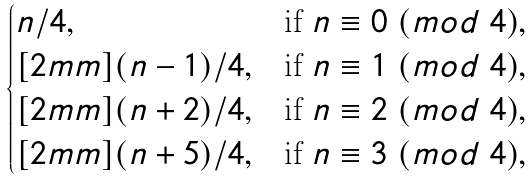<formula> <loc_0><loc_0><loc_500><loc_500>\begin{cases} n / 4 , & \text {if } n \equiv 0 \ ( m o d \ 4 ) , \\ [ 2 m m ] ( n - 1 ) / 4 , & \text {if } n \equiv 1 \ ( m o d \ 4 ) , \\ [ 2 m m ] ( n + 2 ) / 4 , & \text {if } n \equiv 2 \ ( m o d \ 4 ) , \\ [ 2 m m ] ( n + 5 ) / 4 , & \text {if } n \equiv 3 \ ( m o d \ 4 ) , \end{cases}</formula> 